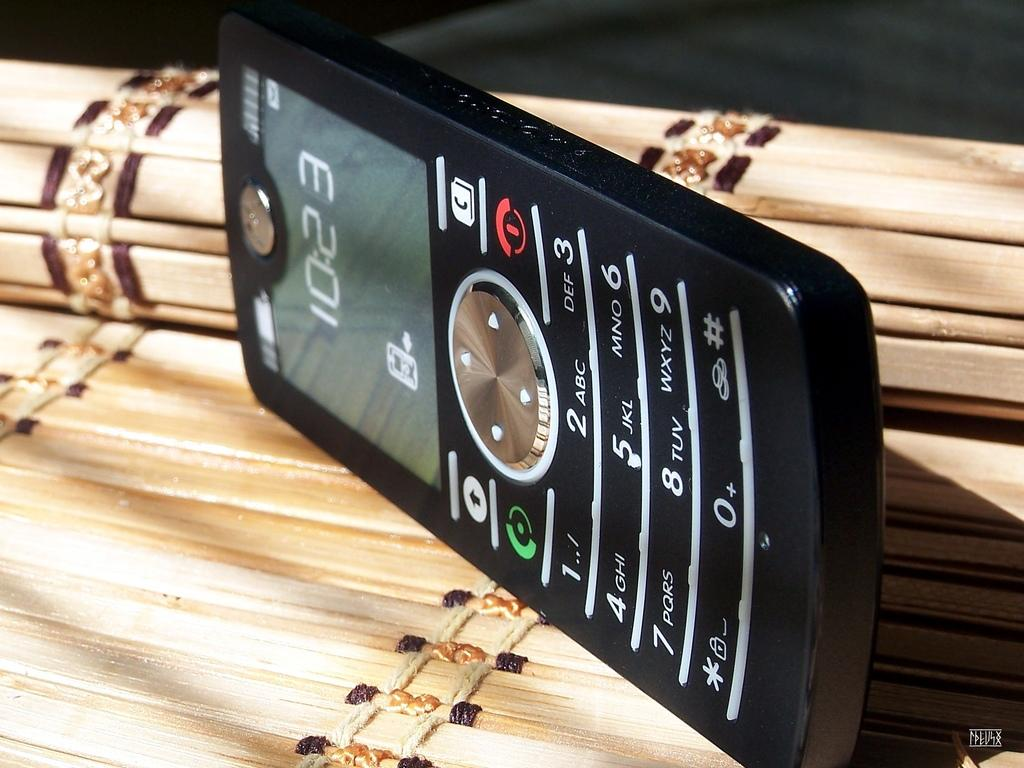<image>
Share a concise interpretation of the image provided. Cellphone that shows the time at 10:23 laying on it's side. 